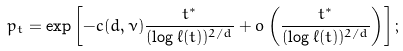<formula> <loc_0><loc_0><loc_500><loc_500>p _ { t } = \exp \left [ - c ( d , \nu ) \frac { t ^ { * } } { ( \log \ell ( t ) ) ^ { 2 / d } } + o \left ( \frac { t ^ { * } } { ( \log \ell ( t ) ) ^ { 2 / d } } \right ) \right ] ;</formula> 